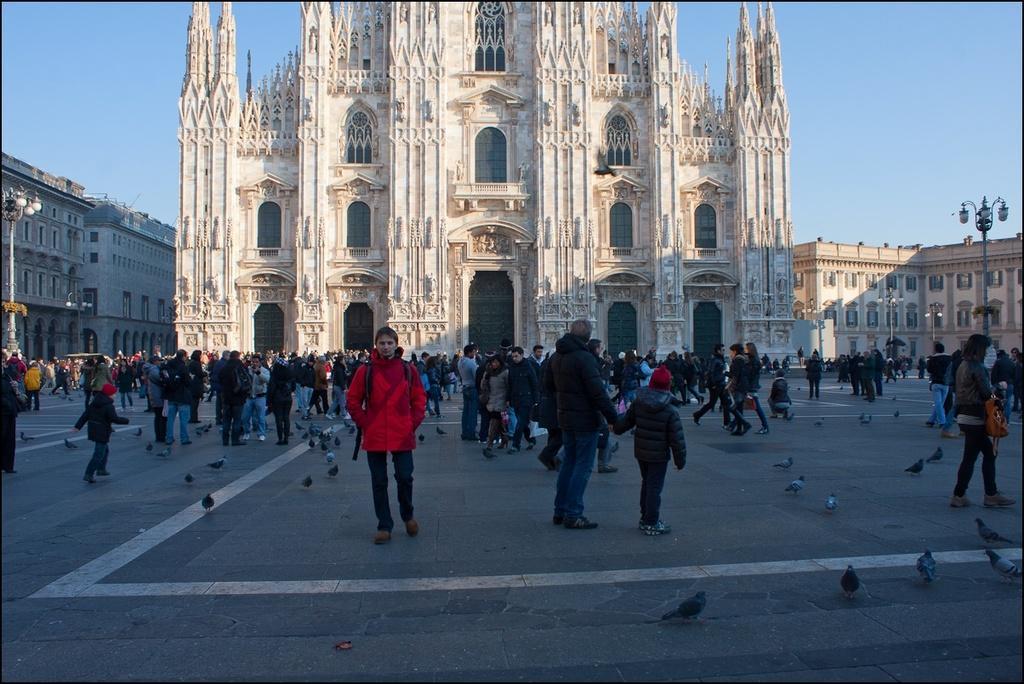Can you describe this image briefly? In this image at front people are standing on the road and we can also see pigeons on the road. At the center of the image there is a church. On both right and left side of the image there are buildings, streetlights. At the background there is sky. 